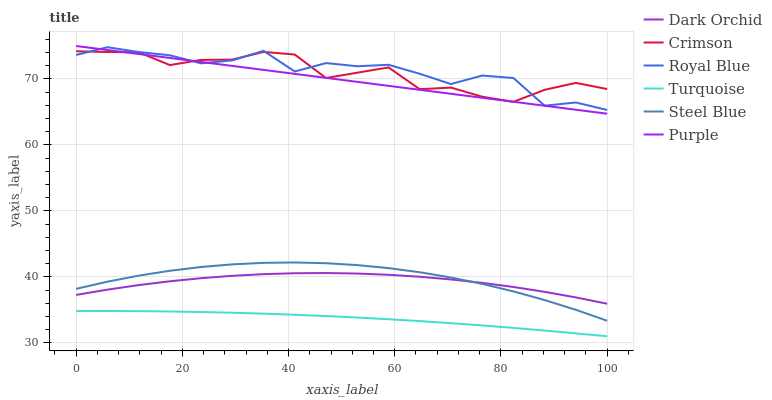Does Turquoise have the minimum area under the curve?
Answer yes or no. Yes. Does Royal Blue have the maximum area under the curve?
Answer yes or no. Yes. Does Purple have the minimum area under the curve?
Answer yes or no. No. Does Purple have the maximum area under the curve?
Answer yes or no. No. Is Purple the smoothest?
Answer yes or no. Yes. Is Royal Blue the roughest?
Answer yes or no. Yes. Is Steel Blue the smoothest?
Answer yes or no. No. Is Steel Blue the roughest?
Answer yes or no. No. Does Purple have the lowest value?
Answer yes or no. No. Does Purple have the highest value?
Answer yes or no. Yes. Does Steel Blue have the highest value?
Answer yes or no. No. Is Steel Blue less than Royal Blue?
Answer yes or no. Yes. Is Crimson greater than Dark Orchid?
Answer yes or no. Yes. Does Steel Blue intersect Royal Blue?
Answer yes or no. No. 